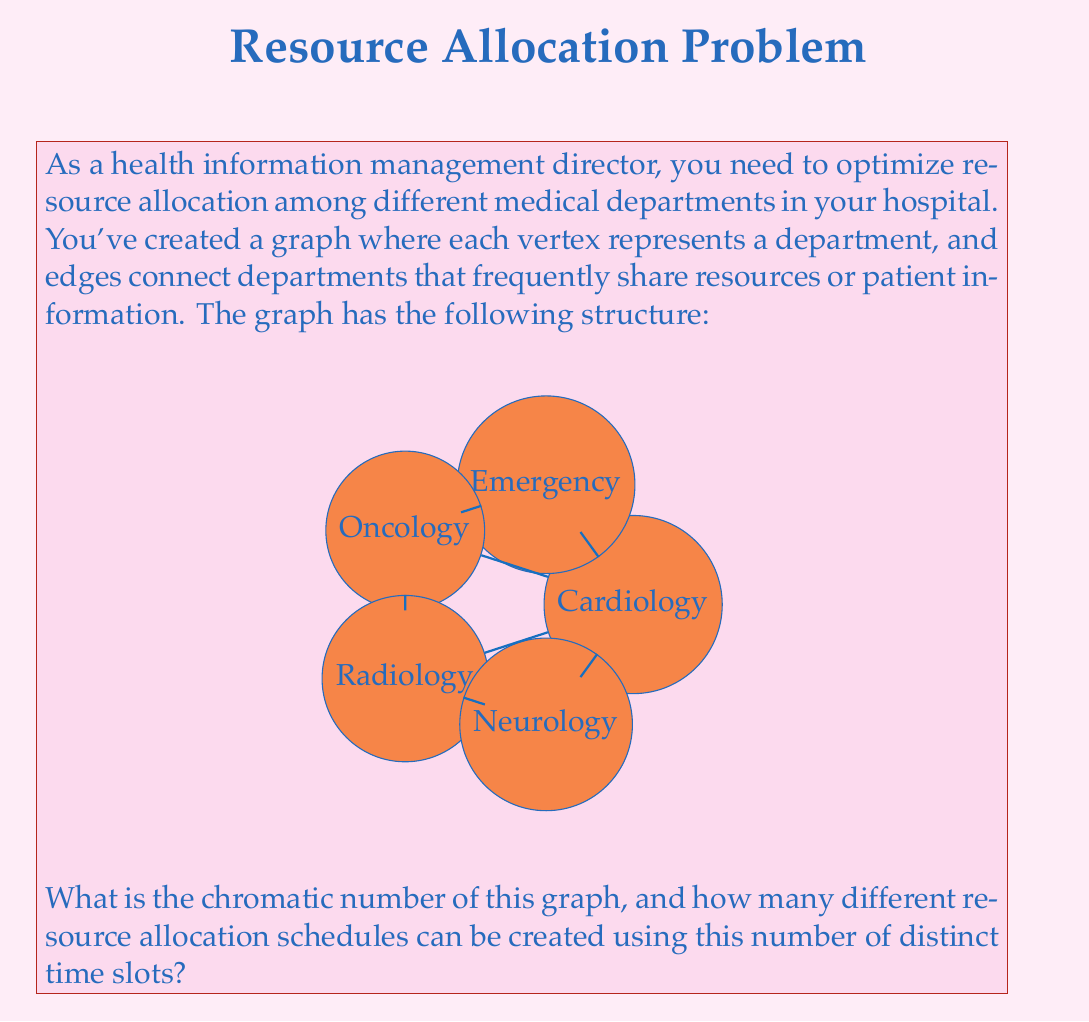Solve this math problem. To solve this problem, we need to follow these steps:

1. Determine the chromatic number of the graph:
   The chromatic number is the minimum number of colors needed to color the vertices of a graph such that no two adjacent vertices share the same color.

   Let's color the graph:
   - Cardiology: Color 1
   - Neurology: Color 2
   - Oncology: Color 3
   - Radiology: Color 1 (it's not adjacent to Cardiology)
   - Emergency: Color 2 (it's only adjacent to Cardiology and Oncology)

   We used 3 colors, and it's impossible to use fewer because Cardiology, Neurology, and Oncology form a triangle (complete subgraph of order 3). Therefore, the chromatic number is 3.

2. Calculate the number of possible resource allocation schedules:
   With 3 distinct time slots (corresponding to the 3 colors), we need to assign each department to one of these slots. This is equivalent to the number of surjective functions from a set of 5 elements (departments) to a set of 3 elements (time slots).

   The formula for the number of surjective functions is:

   $$S(n,k) = \sum_{i=0}^k (-1)^i \binom{k}{i} (k-i)^n$$

   Where $n$ is the number of elements in the domain (5 departments) and $k$ is the number of elements in the codomain (3 time slots).

   Plugging in the values:

   $$S(5,3) = \sum_{i=0}^3 (-1)^i \binom{3}{i} (3-i)^5$$

   $$= \binom{3}{0}3^5 - \binom{3}{1}2^5 + \binom{3}{2}1^5 - \binom{3}{3}0^5$$

   $$= 1 \cdot 243 - 3 \cdot 32 + 3 \cdot 1 - 1 \cdot 0$$

   $$= 243 - 96 + 3$$

   $$= 150$$

Therefore, there are 150 different ways to allocate the resources using 3 distinct time slots.
Answer: The chromatic number of the graph is 3, and there are 150 different possible resource allocation schedules using 3 distinct time slots. 